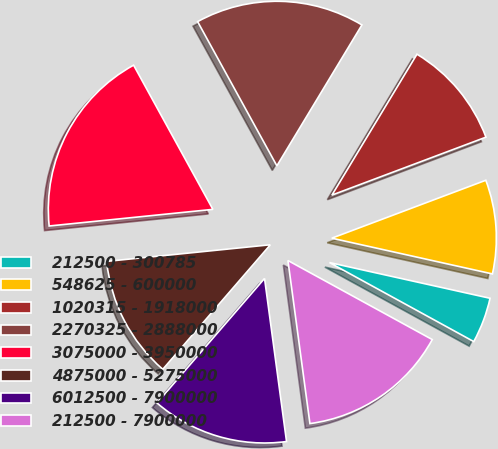<chart> <loc_0><loc_0><loc_500><loc_500><pie_chart><fcel>212500 - 300785<fcel>548625 - 600000<fcel>1020315 - 1918000<fcel>2270325 - 2888000<fcel>3075000 - 3950000<fcel>4875000 - 5275000<fcel>6012500 - 7900000<fcel>212500 - 7900000<nl><fcel>4.49%<fcel>9.21%<fcel>10.63%<fcel>16.64%<fcel>18.61%<fcel>12.05%<fcel>13.47%<fcel>14.89%<nl></chart> 